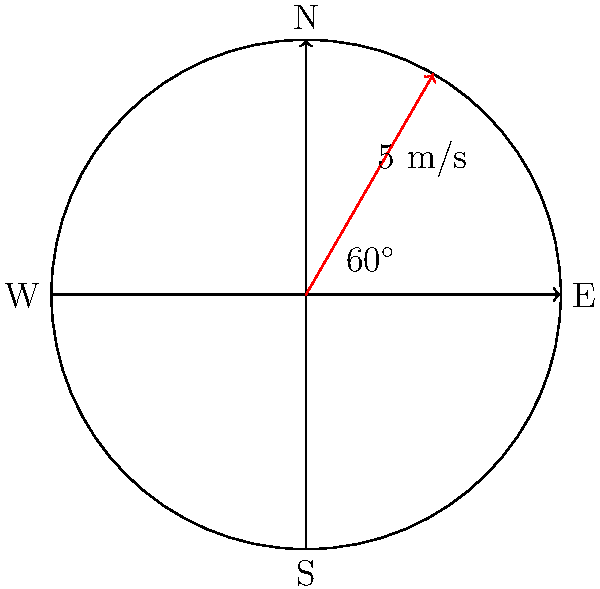A weather station reports wind data using polar coordinates. The wind speed is measured at 5 m/s with a direction of 60° from the positive x-axis (East). Calculate the northward and eastward components of the wind velocity. To solve this problem, we need to convert the polar coordinates to rectangular coordinates. Let's follow these steps:

1) In polar coordinates, we have:
   $r = 5$ m/s (wind speed)
   $\theta = 60°$ (direction from East)

2) To convert to rectangular coordinates, we use these formulas:
   $x = r \cos(\theta)$ (Eastward component)
   $y = r \sin(\theta)$ (Northward component)

3) For the eastward component:
   $x = 5 \cos(60°)$
   $x = 5 \cdot 0.5 = 2.5$ m/s

4) For the northward component:
   $y = 5 \sin(60°)$
   $y = 5 \cdot \frac{\sqrt{3}}{2} \approx 4.33$ m/s

5) Therefore, the wind velocity can be expressed as:
   Eastward component: 2.5 m/s
   Northward component: 4.33 m/s (rounded to two decimal places)
Answer: Eastward: 2.5 m/s, Northward: 4.33 m/s 